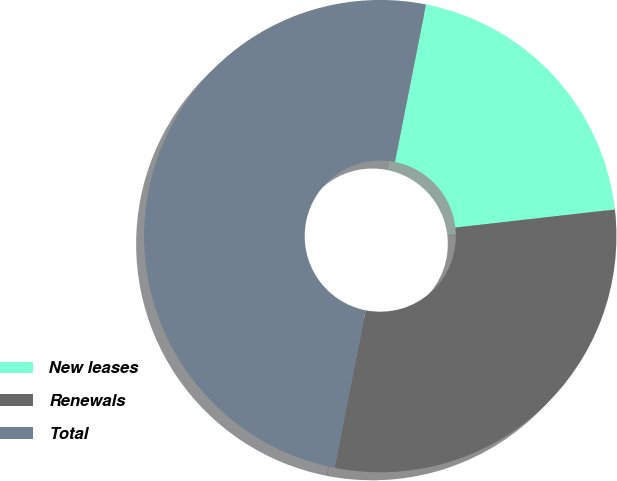Convert chart. <chart><loc_0><loc_0><loc_500><loc_500><pie_chart><fcel>New leases<fcel>Renewals<fcel>Total<nl><fcel>20.1%<fcel>29.9%<fcel>50.0%<nl></chart> 